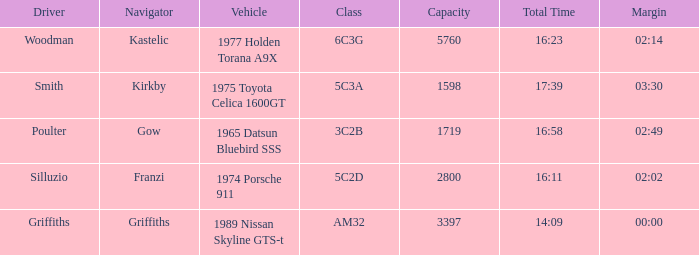What's the lowest capacity when the margin is 03:30? 1598.0. 